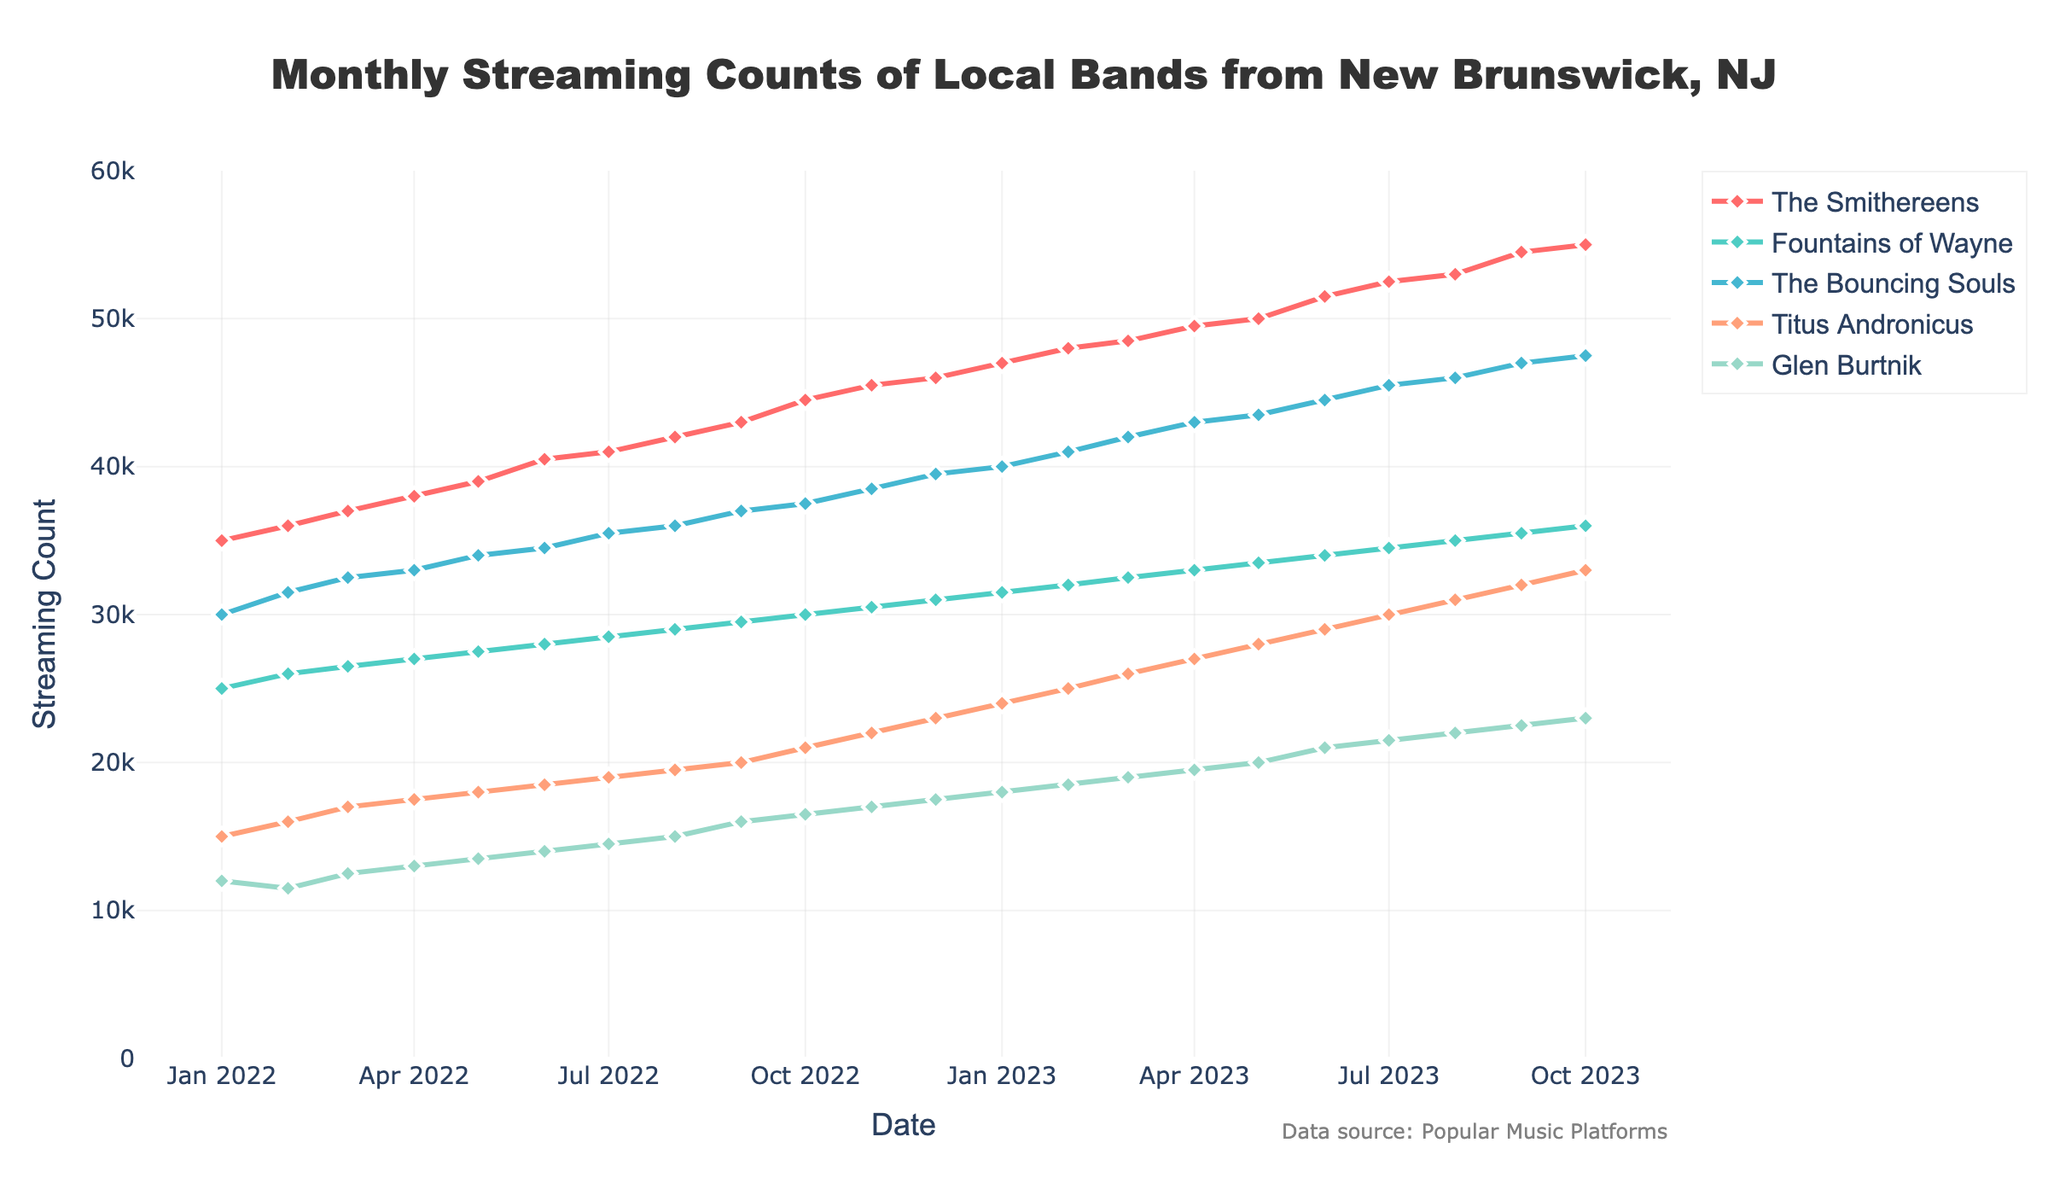What is the title of the plot? The title can be found at the top of the figure, which generally summarizes the data presented in the plot. The title here shows "Monthly Streaming Counts of Local Bands from New Brunswick, NJ".
Answer: Monthly Streaming Counts of Local Bands from New Brunswick, NJ What bands are being shown in the plot? The names of the bands can be found in the legend of the plot, as well as the labels on the y-axis. The bands listed are The Smithereens, Fountains of Wayne, The Bouncing Souls, Titus Andronicus, and Glen Burtnik.
Answer: The Smithereens, Fountains of Wayne, The Bouncing Souls, Titus Andronicus, Glen Burtnik Which band had the highest streaming count in October 2023? To answer this, we need to look at the streaming counts for each band in October 2023. The Smithereens had the highest count at 55,000.
Answer: The Smithereens What is the average monthly streaming count for Titus Andronicus in the first half of 2023? We compute the average by summing the streaming counts for Titus Andronicus from January 2023 to June 2023 (24,000 + 25,000 + 26,000 + 27,000 + 28,000 + 29,000) and then dividing by the number of months, which is 6. Thus, the average is (24,000 + 25,000 + 26,000 + 27,000 + 28,000 + 29,000) / 6 = 159,000 / 6 = 26,500.
Answer: 26,500 Which band showed the most consistent growth in streaming counts over the entire timeframe? To determine this, observe the line trends for each band. A consistently increasing line without dips signifies consistent growth. The Smithereens show the most consistent growth as their streaming counts increased steadily from 35,000 to 55,000 without any significant fluctuations.
Answer: The Smithereens In which month did Glen Burtnik surpass 20,000 streaming counts for the first time? To find this, locate the month where Glen Burtnik's streaming counts first exceed 20,000 in the figure. This happened in June 2023.
Answer: June 2023 During which month did The Bouncing Souls reach 45,000 streaming counts? Look for the intersection between the timeline (months) and the streaming counts line for The Bouncing Souls. The Bouncing Souls reached 45,000 streaming counts in July 2023.
Answer: July 2023 By how much did the streaming count of Fountains of Wayne increase from January 2022 to October 2023? Calculate the difference between counts in January 2022 (25,000) and October 2023 (36,000). The increase is 36,000 - 25,000 = 11,000.
Answer: 11,000 Did any band experience a decline in streaming counts at any point in the dataset? By examining the plot for any downward slopes in the lines representing each band, none of the bands show a decline in streaming counts at any point; all exhibit an overall upward trend.
Answer: No 